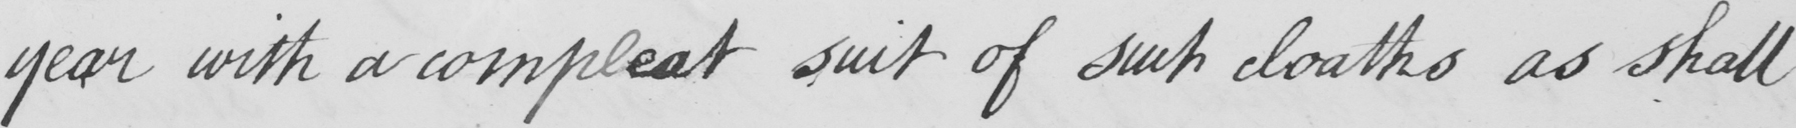Can you read and transcribe this handwriting? year with a compleat suit of such cloaths as shall 